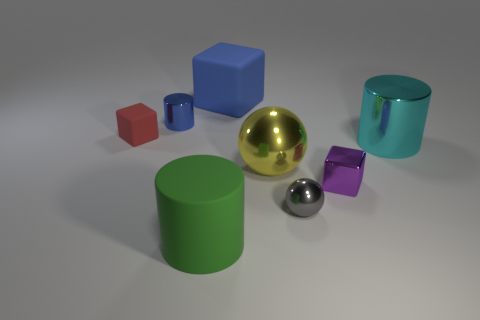Subtract all shiny cylinders. How many cylinders are left? 1 Add 2 cyan objects. How many objects exist? 10 Subtract all green cylinders. How many cylinders are left? 2 Subtract 2 balls. How many balls are left? 0 Subtract all cylinders. How many objects are left? 5 Subtract all purple cylinders. Subtract all green spheres. How many cylinders are left? 3 Subtract all small gray things. Subtract all metallic spheres. How many objects are left? 5 Add 8 small purple things. How many small purple things are left? 9 Add 7 cyan metal cylinders. How many cyan metal cylinders exist? 8 Subtract 0 purple balls. How many objects are left? 8 